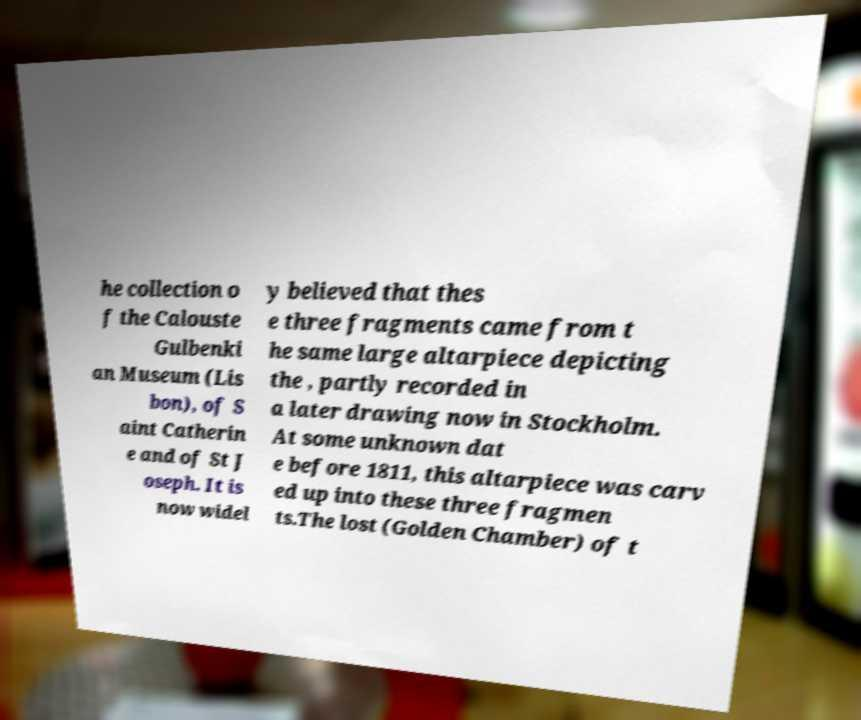Could you extract and type out the text from this image? he collection o f the Calouste Gulbenki an Museum (Lis bon), of S aint Catherin e and of St J oseph. It is now widel y believed that thes e three fragments came from t he same large altarpiece depicting the , partly recorded in a later drawing now in Stockholm. At some unknown dat e before 1811, this altarpiece was carv ed up into these three fragmen ts.The lost (Golden Chamber) of t 